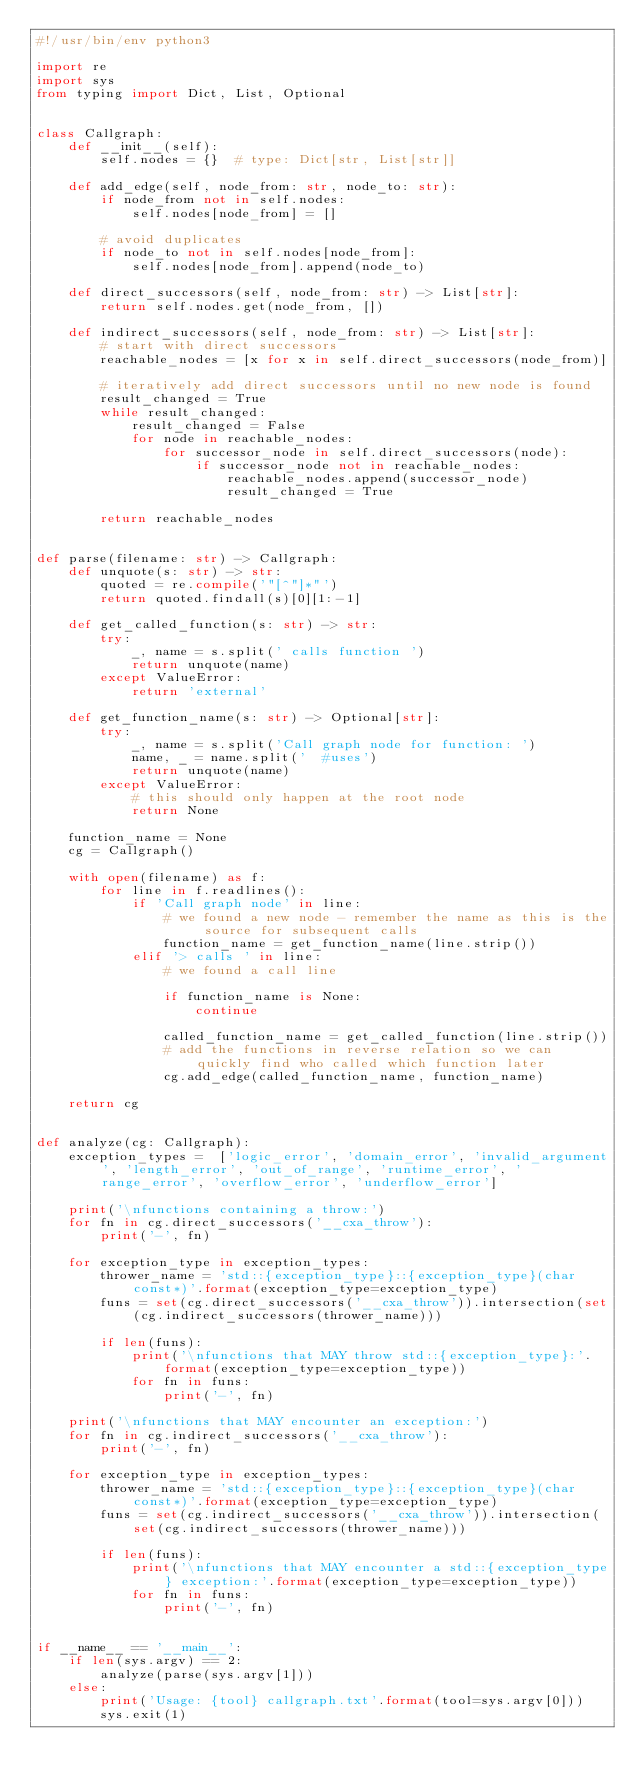Convert code to text. <code><loc_0><loc_0><loc_500><loc_500><_Python_>#!/usr/bin/env python3

import re
import sys
from typing import Dict, List, Optional


class Callgraph:
    def __init__(self):
        self.nodes = {}  # type: Dict[str, List[str]]

    def add_edge(self, node_from: str, node_to: str):
        if node_from not in self.nodes:
            self.nodes[node_from] = []

        # avoid duplicates
        if node_to not in self.nodes[node_from]:
            self.nodes[node_from].append(node_to)

    def direct_successors(self, node_from: str) -> List[str]:
        return self.nodes.get(node_from, [])

    def indirect_successors(self, node_from: str) -> List[str]:
        # start with direct successors
        reachable_nodes = [x for x in self.direct_successors(node_from)]

        # iteratively add direct successors until no new node is found
        result_changed = True
        while result_changed:
            result_changed = False
            for node in reachable_nodes:
                for successor_node in self.direct_successors(node):
                    if successor_node not in reachable_nodes:
                        reachable_nodes.append(successor_node)
                        result_changed = True

        return reachable_nodes


def parse(filename: str) -> Callgraph:
    def unquote(s: str) -> str:
        quoted = re.compile('"[^"]*"')
        return quoted.findall(s)[0][1:-1]

    def get_called_function(s: str) -> str:
        try:
            _, name = s.split(' calls function ')
            return unquote(name)
        except ValueError:
            return 'external'

    def get_function_name(s: str) -> Optional[str]:
        try:
            _, name = s.split('Call graph node for function: ')
            name, _ = name.split('  #uses')
            return unquote(name)
        except ValueError:
            # this should only happen at the root node
            return None

    function_name = None
    cg = Callgraph()

    with open(filename) as f:
        for line in f.readlines():
            if 'Call graph node' in line:
                # we found a new node - remember the name as this is the source for subsequent calls
                function_name = get_function_name(line.strip())
            elif '> calls ' in line:
                # we found a call line

                if function_name is None:
                    continue

                called_function_name = get_called_function(line.strip())
                # add the functions in reverse relation so we can quickly find who called which function later
                cg.add_edge(called_function_name, function_name)

    return cg


def analyze(cg: Callgraph):
    exception_types =  ['logic_error', 'domain_error', 'invalid_argument', 'length_error', 'out_of_range', 'runtime_error', 'range_error', 'overflow_error', 'underflow_error']

    print('\nfunctions containing a throw:')
    for fn in cg.direct_successors('__cxa_throw'):
        print('-', fn)

    for exception_type in exception_types:
        thrower_name = 'std::{exception_type}::{exception_type}(char const*)'.format(exception_type=exception_type)
        funs = set(cg.direct_successors('__cxa_throw')).intersection(set(cg.indirect_successors(thrower_name)))

        if len(funs):
            print('\nfunctions that MAY throw std::{exception_type}:'.format(exception_type=exception_type))
            for fn in funs:
                print('-', fn)

    print('\nfunctions that MAY encounter an exception:')
    for fn in cg.indirect_successors('__cxa_throw'):
        print('-', fn)

    for exception_type in exception_types:
        thrower_name = 'std::{exception_type}::{exception_type}(char const*)'.format(exception_type=exception_type)
        funs = set(cg.indirect_successors('__cxa_throw')).intersection(set(cg.indirect_successors(thrower_name)))

        if len(funs):
            print('\nfunctions that MAY encounter a std::{exception_type} exception:'.format(exception_type=exception_type))
            for fn in funs:
                print('-', fn)


if __name__ == '__main__':
    if len(sys.argv) == 2:
        analyze(parse(sys.argv[1]))
    else:
        print('Usage: {tool} callgraph.txt'.format(tool=sys.argv[0]))
        sys.exit(1)
</code> 